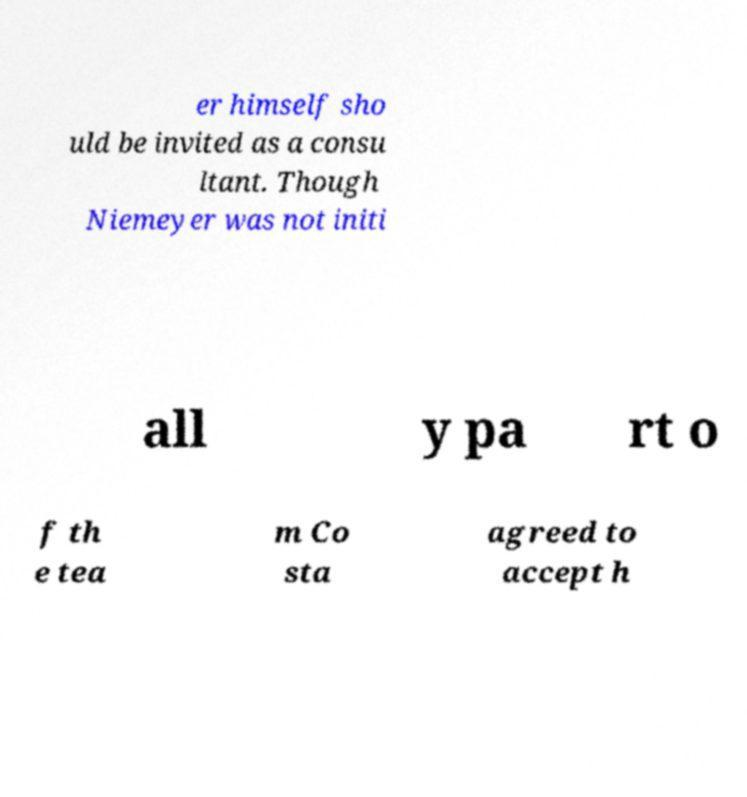What messages or text are displayed in this image? I need them in a readable, typed format. er himself sho uld be invited as a consu ltant. Though Niemeyer was not initi all y pa rt o f th e tea m Co sta agreed to accept h 